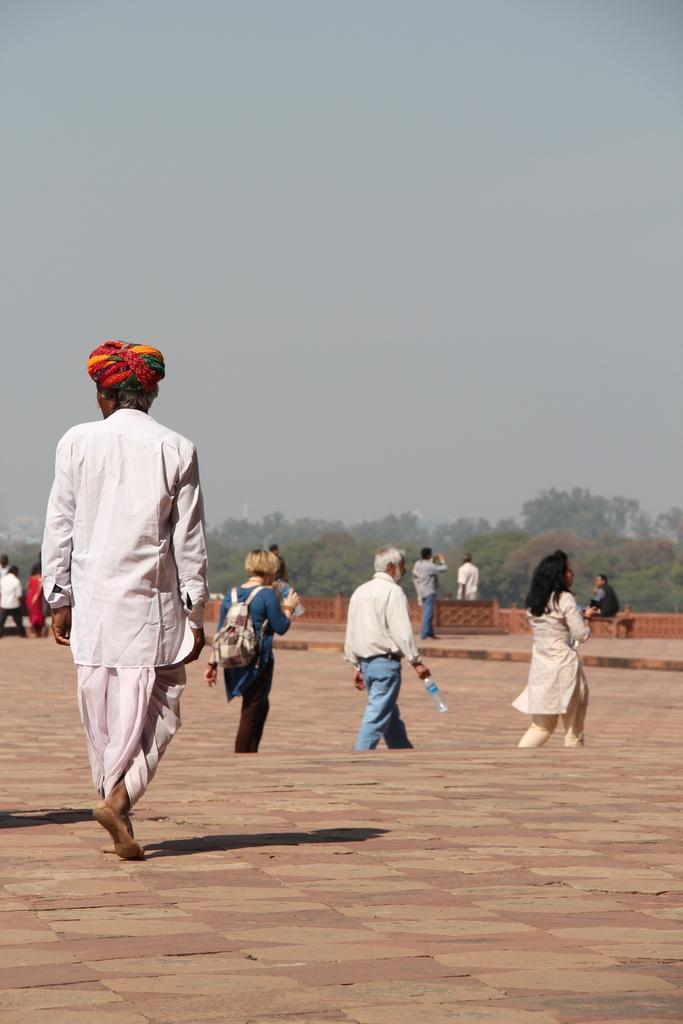What are the persons in the image doing? The persons in the image are on the floor. What can be seen behind the persons? There is a wall visible in the image. What type of natural elements are present in the image? There are trees in the image. What is visible in the distance in the image? The sky is visible in the background of the image. What type of oatmeal is being served on the wall in the image? There is no oatmeal present in the image, and the wall does not appear to be serving any food. Can you tell me how many quills are visible in the image? There are no quills visible in the image. 